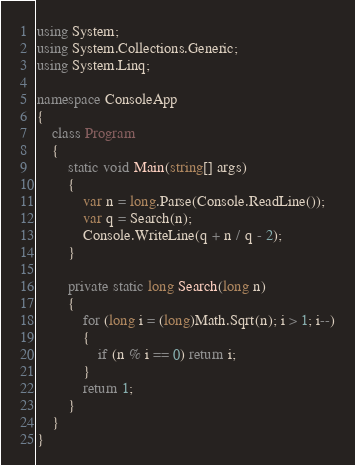Convert code to text. <code><loc_0><loc_0><loc_500><loc_500><_C#_>using System;
using System.Collections.Generic;
using System.Linq;

namespace ConsoleApp
{
    class Program
    {
        static void Main(string[] args)
        {
            var n = long.Parse(Console.ReadLine());
            var q = Search(n);
            Console.WriteLine(q + n / q - 2);
        }

        private static long Search(long n)
        {
            for (long i = (long)Math.Sqrt(n); i > 1; i--)
            {
                if (n % i == 0) return i;
            }
            return 1;
        }
    }
}
</code> 